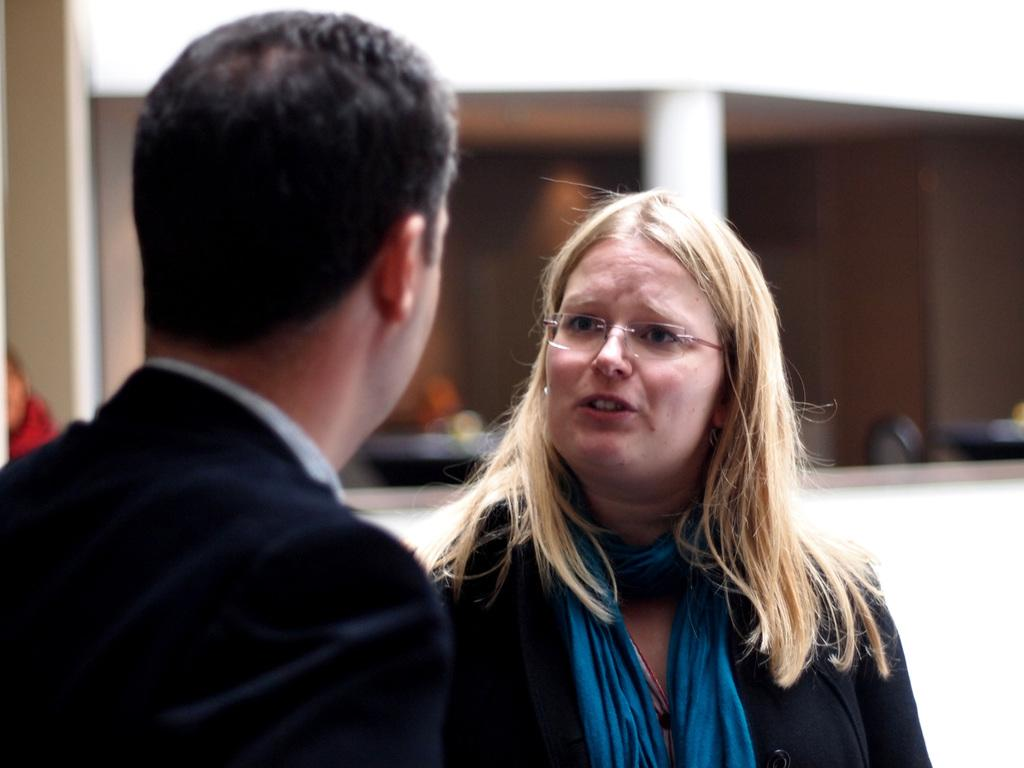How many people are in the image? There are two persons standing in the image. Can you describe one of the persons? One of the persons is wearing spectacles. What can be seen in the background of the image? There is a building. What is visible inside the building? There are objects visible inside the building. What type of pickle is the person holding in the image? There is no pickle present in the image. Is the quilt visible in the image? There is no quilt visible in the image. 